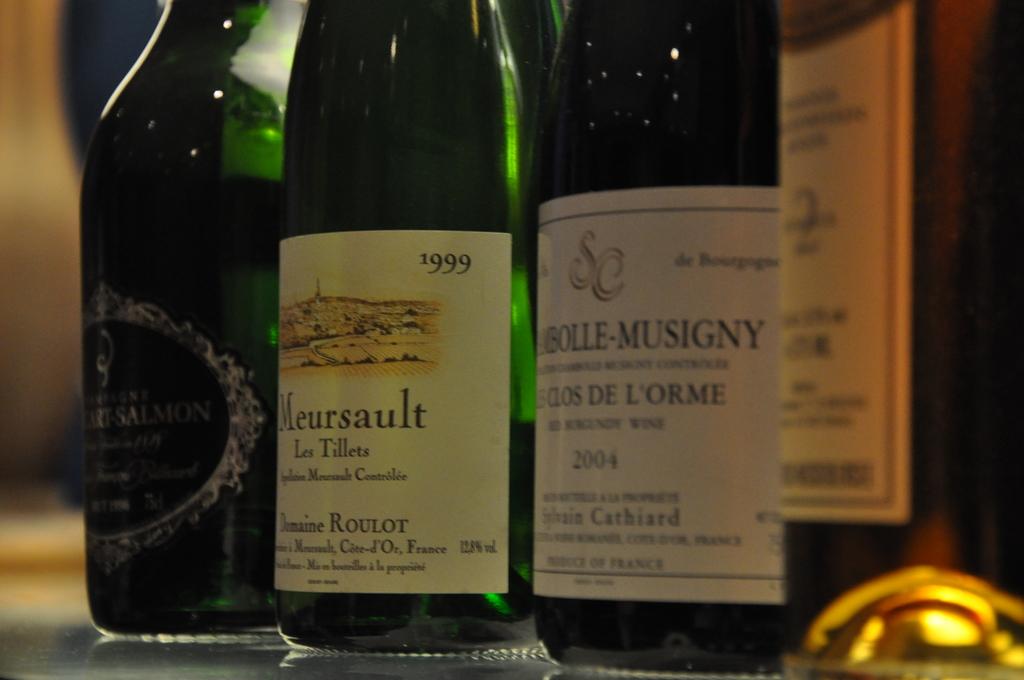What year is the l'orme?
Make the answer very short. 2004. What year is the bottle in the middle?
Your response must be concise. 1999. 